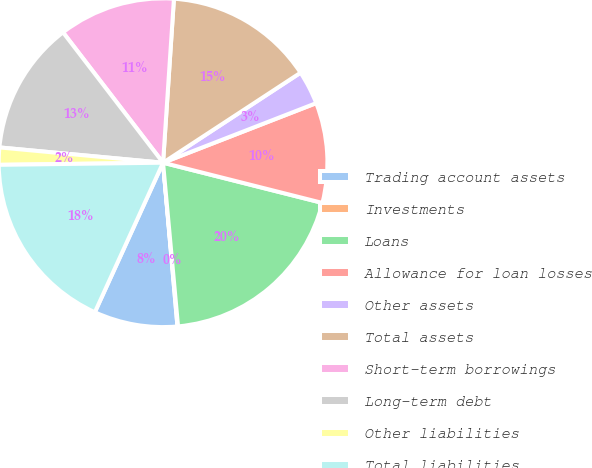<chart> <loc_0><loc_0><loc_500><loc_500><pie_chart><fcel>Trading account assets<fcel>Investments<fcel>Loans<fcel>Allowance for loan losses<fcel>Other assets<fcel>Total assets<fcel>Short-term borrowings<fcel>Long-term debt<fcel>Other liabilities<fcel>Total liabilities<nl><fcel>8.21%<fcel>0.06%<fcel>19.61%<fcel>9.84%<fcel>3.32%<fcel>14.72%<fcel>11.47%<fcel>13.1%<fcel>1.69%<fcel>17.98%<nl></chart> 